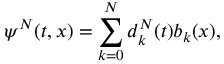<formula> <loc_0><loc_0><loc_500><loc_500>\psi ^ { N } ( t , x ) = \sum _ { k = 0 } ^ { N } d _ { k } ^ { N } ( t ) b _ { k } ( x ) ,</formula> 